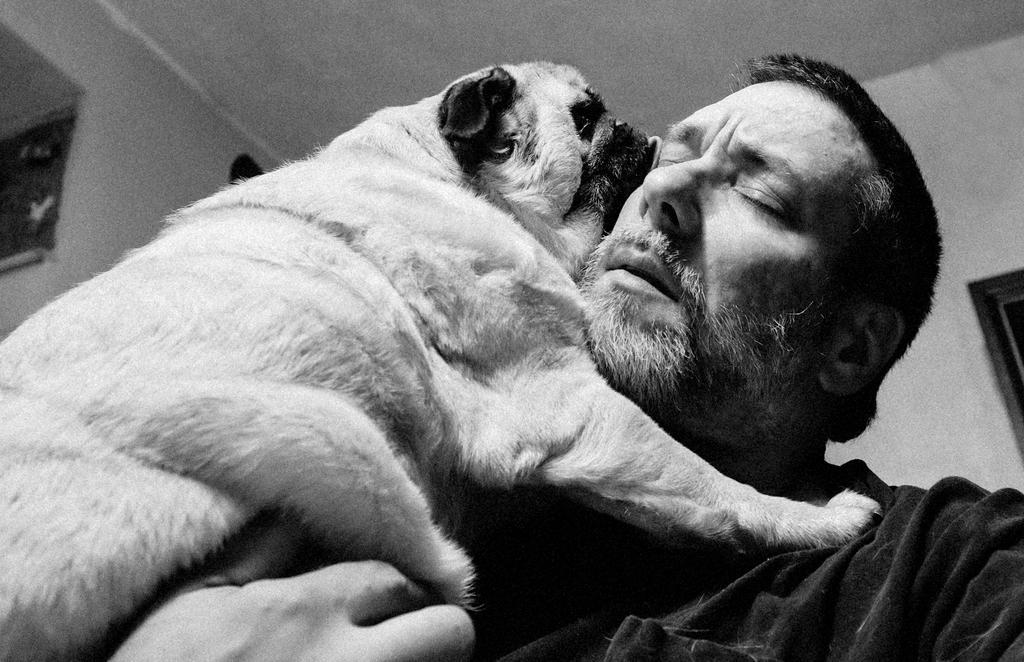Could you give a brief overview of what you see in this image? A person is holding dog. In the background there is roof,wall. 